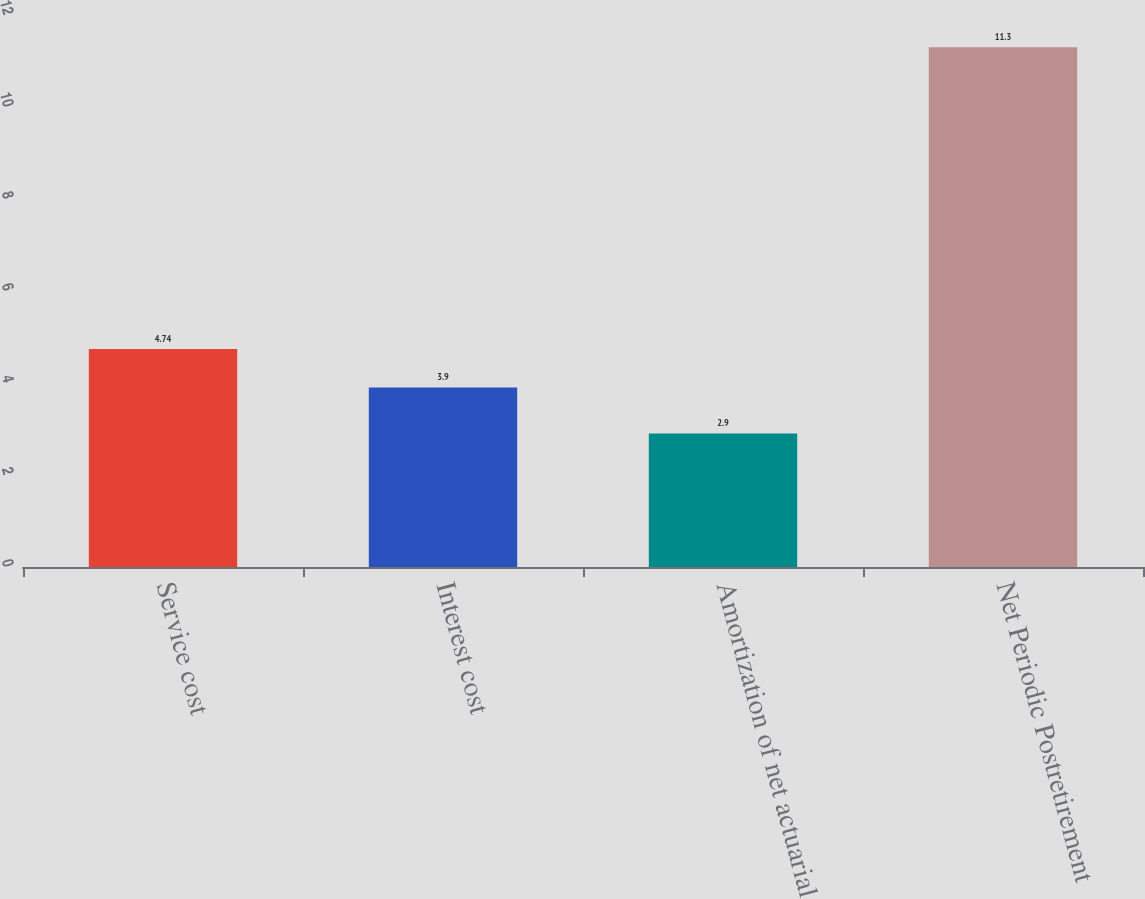Convert chart. <chart><loc_0><loc_0><loc_500><loc_500><bar_chart><fcel>Service cost<fcel>Interest cost<fcel>Amortization of net actuarial<fcel>Net Periodic Postretirement<nl><fcel>4.74<fcel>3.9<fcel>2.9<fcel>11.3<nl></chart> 